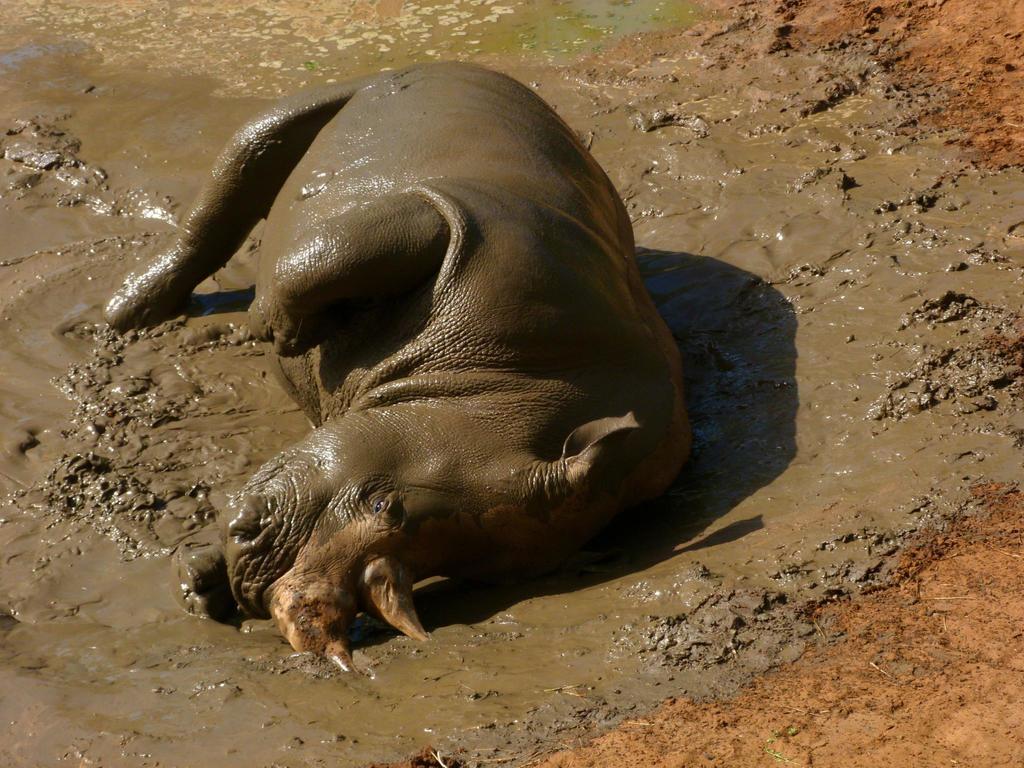Please provide a concise description of this image. In the image I can see a hippopotamus lying in the mud water. 